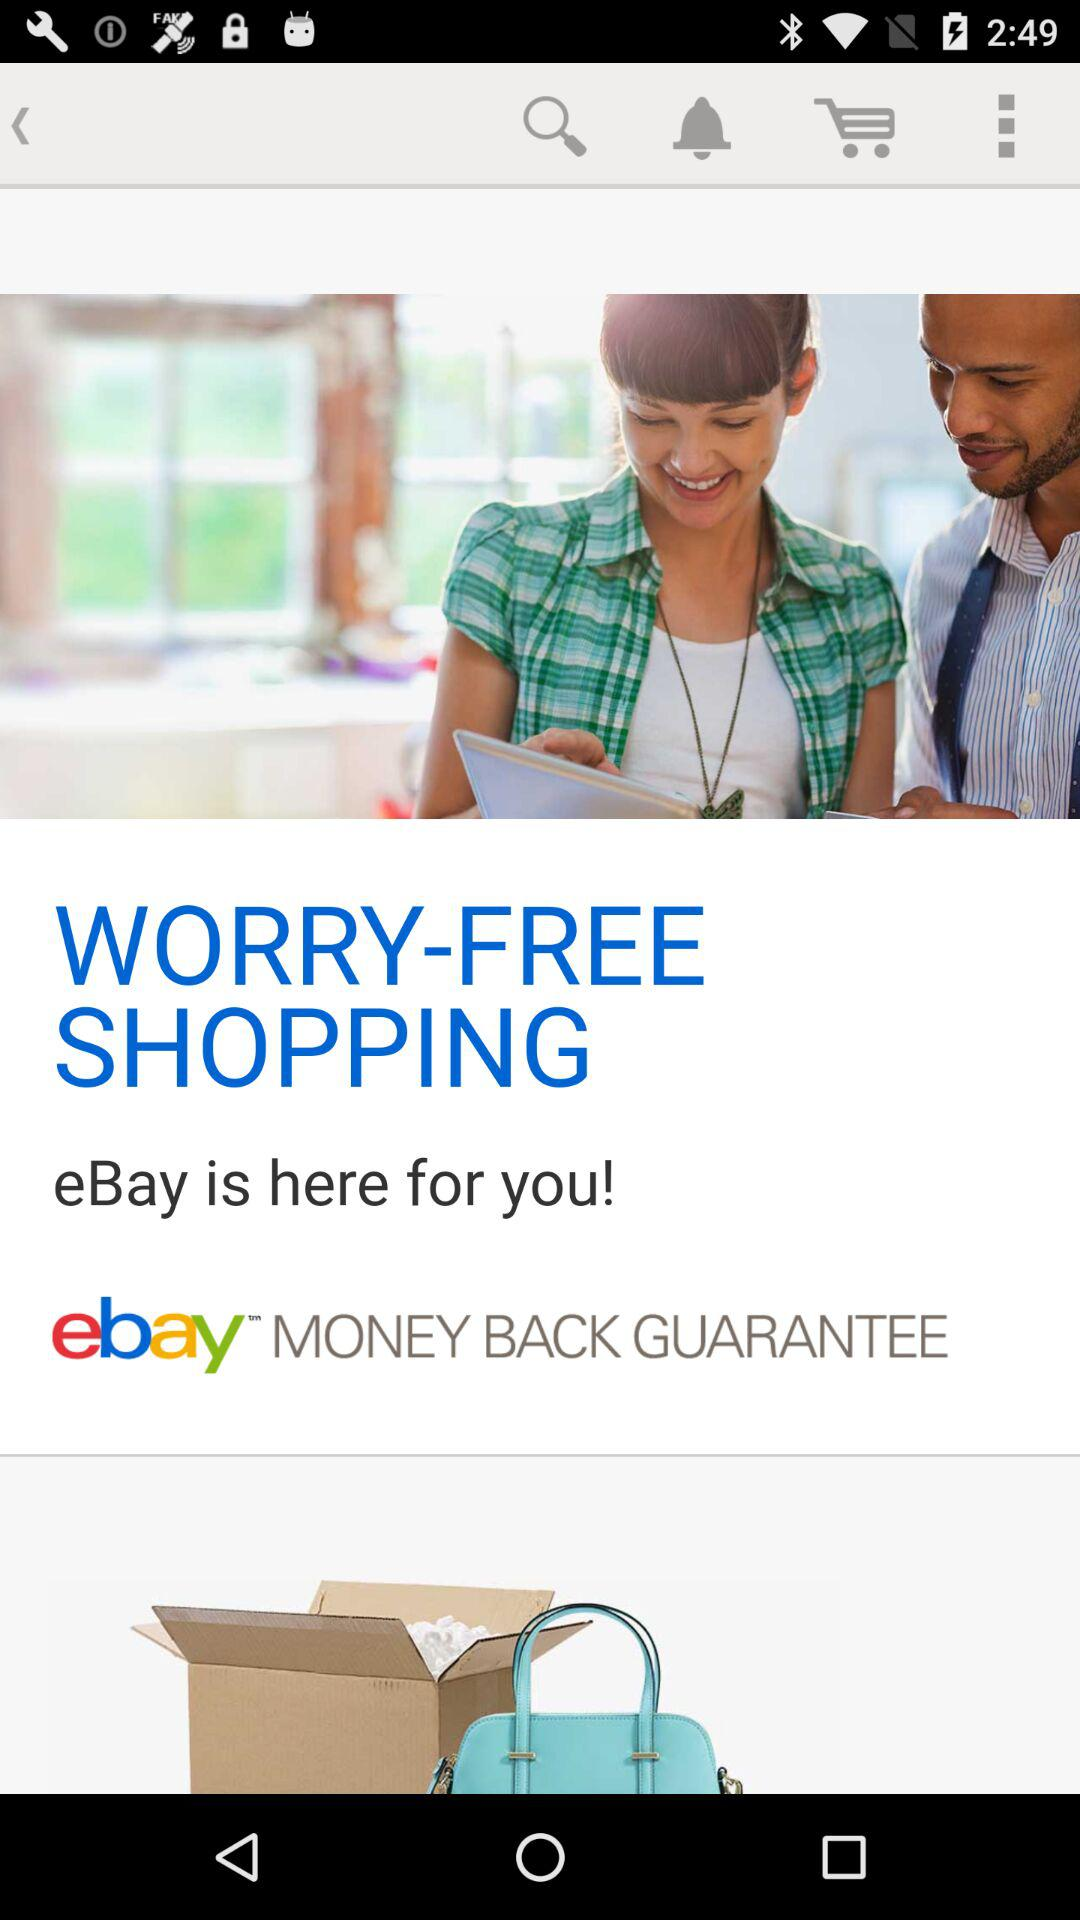What is the app name? The app name is "eBay". 